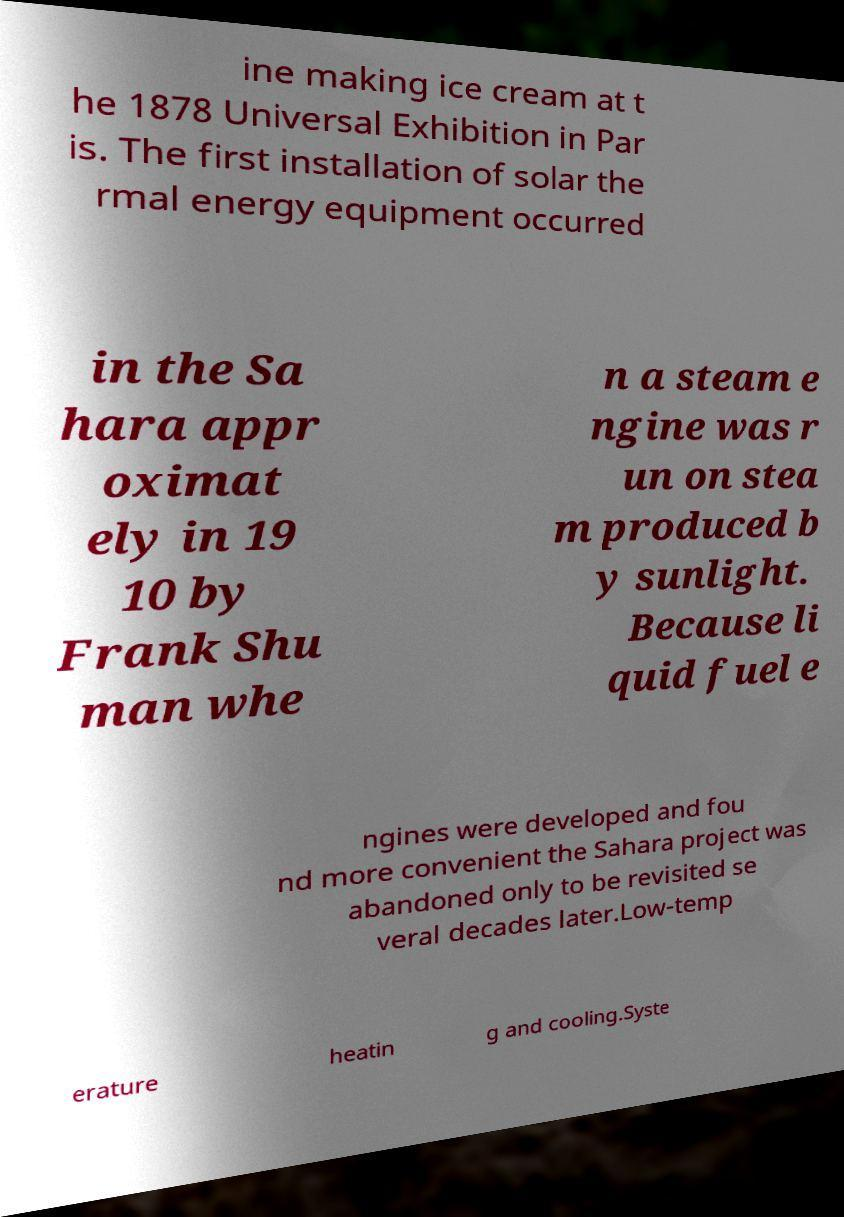Can you accurately transcribe the text from the provided image for me? ine making ice cream at t he 1878 Universal Exhibition in Par is. The first installation of solar the rmal energy equipment occurred in the Sa hara appr oximat ely in 19 10 by Frank Shu man whe n a steam e ngine was r un on stea m produced b y sunlight. Because li quid fuel e ngines were developed and fou nd more convenient the Sahara project was abandoned only to be revisited se veral decades later.Low-temp erature heatin g and cooling.Syste 